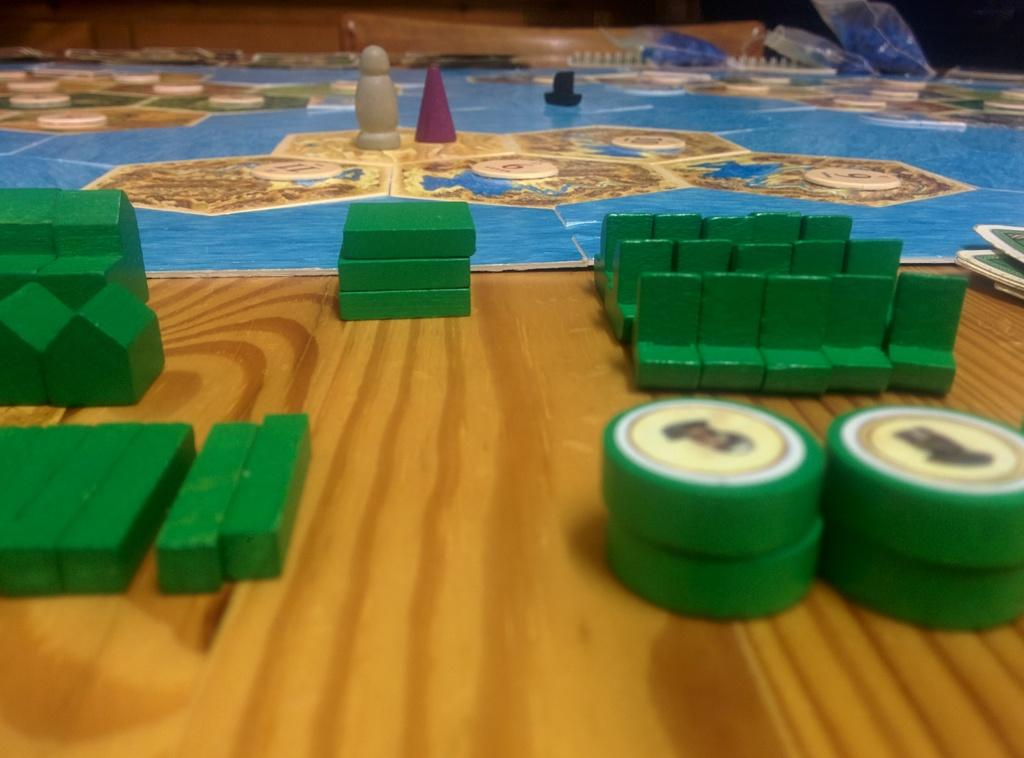What can be found at the bottom of the image? There are objects at the bottom of the image. Where are the cards located in the image? The cards are on the right side of the image. What color are some of the objects in the image? There are green colored objects in the colored objects in the image. What type of son can be seen playing with a thrill on his wrist in the image? There is no son or any reference to a thrill on a wrist present in the image. 